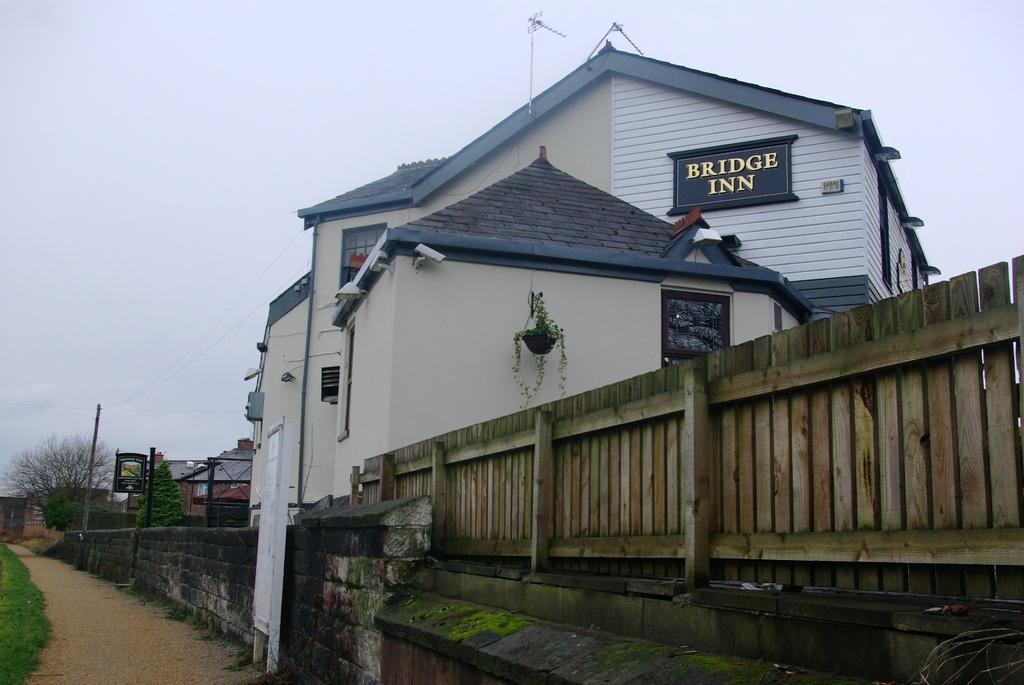How would you summarize this image in a sentence or two? In this image, we can see a wooden fencing and there is a wall, we can see a building, at the top there is a sky which is cloudy. 